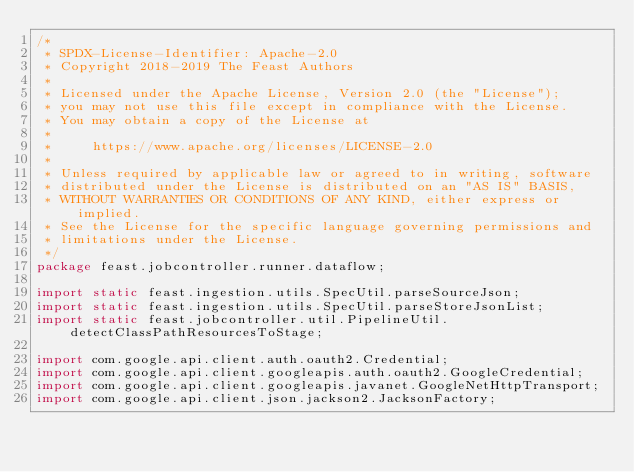Convert code to text. <code><loc_0><loc_0><loc_500><loc_500><_Java_>/*
 * SPDX-License-Identifier: Apache-2.0
 * Copyright 2018-2019 The Feast Authors
 *
 * Licensed under the Apache License, Version 2.0 (the "License");
 * you may not use this file except in compliance with the License.
 * You may obtain a copy of the License at
 *
 *     https://www.apache.org/licenses/LICENSE-2.0
 *
 * Unless required by applicable law or agreed to in writing, software
 * distributed under the License is distributed on an "AS IS" BASIS,
 * WITHOUT WARRANTIES OR CONDITIONS OF ANY KIND, either express or implied.
 * See the License for the specific language governing permissions and
 * limitations under the License.
 */
package feast.jobcontroller.runner.dataflow;

import static feast.ingestion.utils.SpecUtil.parseSourceJson;
import static feast.ingestion.utils.SpecUtil.parseStoreJsonList;
import static feast.jobcontroller.util.PipelineUtil.detectClassPathResourcesToStage;

import com.google.api.client.auth.oauth2.Credential;
import com.google.api.client.googleapis.auth.oauth2.GoogleCredential;
import com.google.api.client.googleapis.javanet.GoogleNetHttpTransport;
import com.google.api.client.json.jackson2.JacksonFactory;</code> 